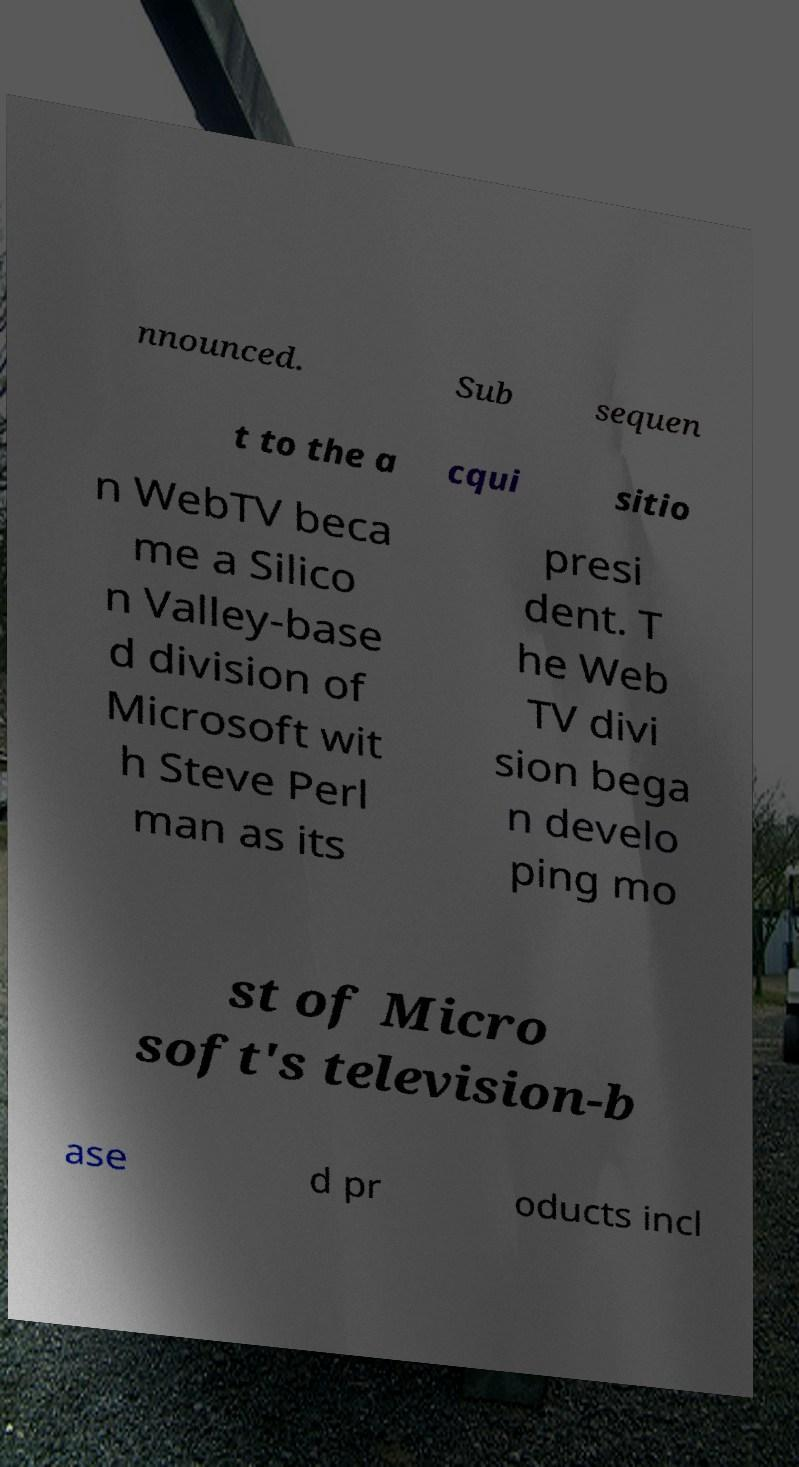Could you extract and type out the text from this image? nnounced. Sub sequen t to the a cqui sitio n WebTV beca me a Silico n Valley-base d division of Microsoft wit h Steve Perl man as its presi dent. T he Web TV divi sion bega n develo ping mo st of Micro soft's television-b ase d pr oducts incl 